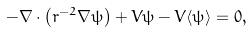Convert formula to latex. <formula><loc_0><loc_0><loc_500><loc_500>- \nabla \cdot \left ( r ^ { - 2 } \nabla \psi \right ) + V \psi - V \langle \psi \rangle = 0 ,</formula> 